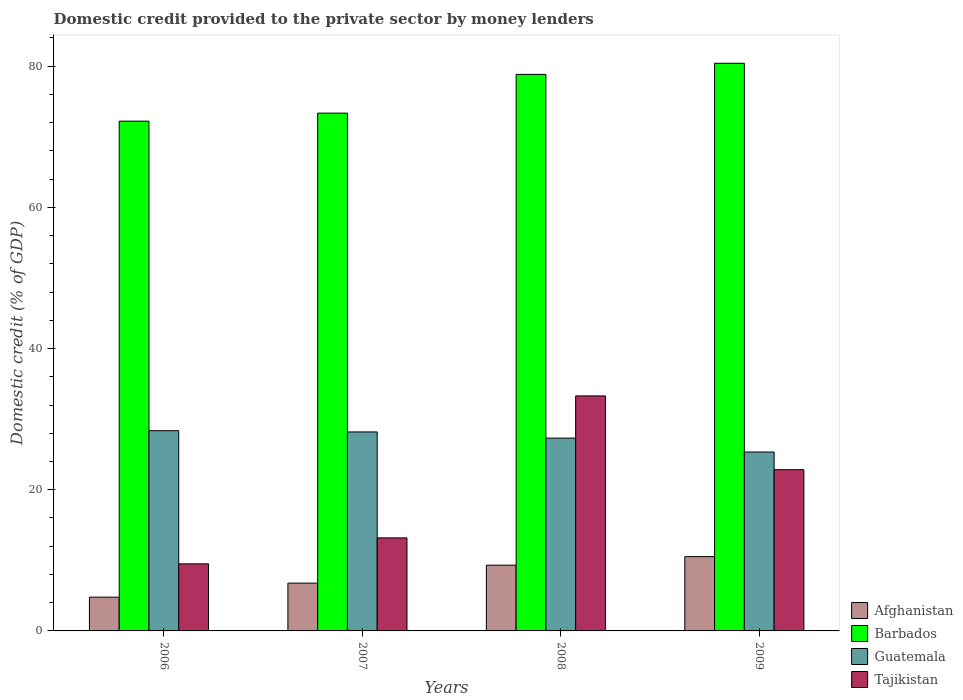How many groups of bars are there?
Your answer should be very brief. 4. Are the number of bars per tick equal to the number of legend labels?
Keep it short and to the point. Yes. Are the number of bars on each tick of the X-axis equal?
Your answer should be very brief. Yes. How many bars are there on the 3rd tick from the right?
Your response must be concise. 4. What is the domestic credit provided to the private sector by money lenders in Tajikistan in 2009?
Your answer should be compact. 22.84. Across all years, what is the maximum domestic credit provided to the private sector by money lenders in Guatemala?
Provide a succinct answer. 28.36. Across all years, what is the minimum domestic credit provided to the private sector by money lenders in Barbados?
Ensure brevity in your answer.  72.21. In which year was the domestic credit provided to the private sector by money lenders in Tajikistan minimum?
Provide a short and direct response. 2006. What is the total domestic credit provided to the private sector by money lenders in Afghanistan in the graph?
Your answer should be very brief. 31.39. What is the difference between the domestic credit provided to the private sector by money lenders in Tajikistan in 2008 and that in 2009?
Provide a short and direct response. 10.45. What is the difference between the domestic credit provided to the private sector by money lenders in Tajikistan in 2009 and the domestic credit provided to the private sector by money lenders in Afghanistan in 2006?
Your answer should be very brief. 18.06. What is the average domestic credit provided to the private sector by money lenders in Guatemala per year?
Your response must be concise. 27.3. In the year 2006, what is the difference between the domestic credit provided to the private sector by money lenders in Afghanistan and domestic credit provided to the private sector by money lenders in Barbados?
Your response must be concise. -67.42. In how many years, is the domestic credit provided to the private sector by money lenders in Guatemala greater than 20 %?
Provide a succinct answer. 4. What is the ratio of the domestic credit provided to the private sector by money lenders in Tajikistan in 2006 to that in 2007?
Provide a short and direct response. 0.72. Is the domestic credit provided to the private sector by money lenders in Barbados in 2006 less than that in 2007?
Your answer should be compact. Yes. Is the difference between the domestic credit provided to the private sector by money lenders in Afghanistan in 2008 and 2009 greater than the difference between the domestic credit provided to the private sector by money lenders in Barbados in 2008 and 2009?
Provide a succinct answer. Yes. What is the difference between the highest and the second highest domestic credit provided to the private sector by money lenders in Barbados?
Offer a terse response. 1.58. What is the difference between the highest and the lowest domestic credit provided to the private sector by money lenders in Guatemala?
Give a very brief answer. 3.02. In how many years, is the domestic credit provided to the private sector by money lenders in Barbados greater than the average domestic credit provided to the private sector by money lenders in Barbados taken over all years?
Ensure brevity in your answer.  2. Is the sum of the domestic credit provided to the private sector by money lenders in Barbados in 2006 and 2008 greater than the maximum domestic credit provided to the private sector by money lenders in Tajikistan across all years?
Provide a short and direct response. Yes. Is it the case that in every year, the sum of the domestic credit provided to the private sector by money lenders in Tajikistan and domestic credit provided to the private sector by money lenders in Guatemala is greater than the sum of domestic credit provided to the private sector by money lenders in Afghanistan and domestic credit provided to the private sector by money lenders in Barbados?
Give a very brief answer. No. What does the 2nd bar from the left in 2008 represents?
Your answer should be very brief. Barbados. What does the 4th bar from the right in 2007 represents?
Provide a short and direct response. Afghanistan. Is it the case that in every year, the sum of the domestic credit provided to the private sector by money lenders in Tajikistan and domestic credit provided to the private sector by money lenders in Barbados is greater than the domestic credit provided to the private sector by money lenders in Afghanistan?
Make the answer very short. Yes. How many bars are there?
Provide a succinct answer. 16. Are all the bars in the graph horizontal?
Your response must be concise. No. How many years are there in the graph?
Give a very brief answer. 4. What is the difference between two consecutive major ticks on the Y-axis?
Ensure brevity in your answer.  20. Does the graph contain any zero values?
Ensure brevity in your answer.  No. Does the graph contain grids?
Make the answer very short. No. How are the legend labels stacked?
Offer a very short reply. Vertical. What is the title of the graph?
Your answer should be very brief. Domestic credit provided to the private sector by money lenders. What is the label or title of the Y-axis?
Your answer should be compact. Domestic credit (% of GDP). What is the Domestic credit (% of GDP) in Afghanistan in 2006?
Provide a short and direct response. 4.78. What is the Domestic credit (% of GDP) of Barbados in 2006?
Provide a succinct answer. 72.21. What is the Domestic credit (% of GDP) in Guatemala in 2006?
Offer a terse response. 28.36. What is the Domestic credit (% of GDP) of Tajikistan in 2006?
Offer a very short reply. 9.5. What is the Domestic credit (% of GDP) of Afghanistan in 2007?
Give a very brief answer. 6.77. What is the Domestic credit (% of GDP) of Barbados in 2007?
Keep it short and to the point. 73.35. What is the Domestic credit (% of GDP) of Guatemala in 2007?
Your answer should be compact. 28.18. What is the Domestic credit (% of GDP) in Tajikistan in 2007?
Your answer should be very brief. 13.18. What is the Domestic credit (% of GDP) in Afghanistan in 2008?
Provide a succinct answer. 9.31. What is the Domestic credit (% of GDP) of Barbados in 2008?
Ensure brevity in your answer.  78.83. What is the Domestic credit (% of GDP) of Guatemala in 2008?
Provide a succinct answer. 27.31. What is the Domestic credit (% of GDP) in Tajikistan in 2008?
Offer a terse response. 33.29. What is the Domestic credit (% of GDP) in Afghanistan in 2009?
Your answer should be very brief. 10.53. What is the Domestic credit (% of GDP) in Barbados in 2009?
Make the answer very short. 80.41. What is the Domestic credit (% of GDP) in Guatemala in 2009?
Give a very brief answer. 25.34. What is the Domestic credit (% of GDP) of Tajikistan in 2009?
Provide a short and direct response. 22.84. Across all years, what is the maximum Domestic credit (% of GDP) of Afghanistan?
Provide a short and direct response. 10.53. Across all years, what is the maximum Domestic credit (% of GDP) of Barbados?
Your response must be concise. 80.41. Across all years, what is the maximum Domestic credit (% of GDP) in Guatemala?
Offer a terse response. 28.36. Across all years, what is the maximum Domestic credit (% of GDP) of Tajikistan?
Offer a terse response. 33.29. Across all years, what is the minimum Domestic credit (% of GDP) in Afghanistan?
Ensure brevity in your answer.  4.78. Across all years, what is the minimum Domestic credit (% of GDP) in Barbados?
Your answer should be very brief. 72.21. Across all years, what is the minimum Domestic credit (% of GDP) in Guatemala?
Offer a terse response. 25.34. Across all years, what is the minimum Domestic credit (% of GDP) of Tajikistan?
Ensure brevity in your answer.  9.5. What is the total Domestic credit (% of GDP) in Afghanistan in the graph?
Your answer should be very brief. 31.39. What is the total Domestic credit (% of GDP) of Barbados in the graph?
Your response must be concise. 304.79. What is the total Domestic credit (% of GDP) of Guatemala in the graph?
Your answer should be compact. 109.2. What is the total Domestic credit (% of GDP) of Tajikistan in the graph?
Your answer should be compact. 78.81. What is the difference between the Domestic credit (% of GDP) in Afghanistan in 2006 and that in 2007?
Ensure brevity in your answer.  -1.99. What is the difference between the Domestic credit (% of GDP) of Barbados in 2006 and that in 2007?
Offer a terse response. -1.14. What is the difference between the Domestic credit (% of GDP) in Guatemala in 2006 and that in 2007?
Make the answer very short. 0.18. What is the difference between the Domestic credit (% of GDP) in Tajikistan in 2006 and that in 2007?
Provide a short and direct response. -3.68. What is the difference between the Domestic credit (% of GDP) of Afghanistan in 2006 and that in 2008?
Your response must be concise. -4.53. What is the difference between the Domestic credit (% of GDP) in Barbados in 2006 and that in 2008?
Give a very brief answer. -6.62. What is the difference between the Domestic credit (% of GDP) of Guatemala in 2006 and that in 2008?
Your answer should be very brief. 1.05. What is the difference between the Domestic credit (% of GDP) in Tajikistan in 2006 and that in 2008?
Your answer should be compact. -23.79. What is the difference between the Domestic credit (% of GDP) in Afghanistan in 2006 and that in 2009?
Keep it short and to the point. -5.74. What is the difference between the Domestic credit (% of GDP) in Barbados in 2006 and that in 2009?
Make the answer very short. -8.2. What is the difference between the Domestic credit (% of GDP) in Guatemala in 2006 and that in 2009?
Provide a succinct answer. 3.02. What is the difference between the Domestic credit (% of GDP) in Tajikistan in 2006 and that in 2009?
Provide a short and direct response. -13.34. What is the difference between the Domestic credit (% of GDP) in Afghanistan in 2007 and that in 2008?
Give a very brief answer. -2.54. What is the difference between the Domestic credit (% of GDP) in Barbados in 2007 and that in 2008?
Ensure brevity in your answer.  -5.48. What is the difference between the Domestic credit (% of GDP) in Guatemala in 2007 and that in 2008?
Your response must be concise. 0.87. What is the difference between the Domestic credit (% of GDP) of Tajikistan in 2007 and that in 2008?
Offer a very short reply. -20.11. What is the difference between the Domestic credit (% of GDP) of Afghanistan in 2007 and that in 2009?
Your answer should be very brief. -3.76. What is the difference between the Domestic credit (% of GDP) in Barbados in 2007 and that in 2009?
Provide a short and direct response. -7.06. What is the difference between the Domestic credit (% of GDP) in Guatemala in 2007 and that in 2009?
Keep it short and to the point. 2.84. What is the difference between the Domestic credit (% of GDP) in Tajikistan in 2007 and that in 2009?
Ensure brevity in your answer.  -9.66. What is the difference between the Domestic credit (% of GDP) in Afghanistan in 2008 and that in 2009?
Give a very brief answer. -1.21. What is the difference between the Domestic credit (% of GDP) in Barbados in 2008 and that in 2009?
Offer a terse response. -1.58. What is the difference between the Domestic credit (% of GDP) of Guatemala in 2008 and that in 2009?
Provide a succinct answer. 1.97. What is the difference between the Domestic credit (% of GDP) in Tajikistan in 2008 and that in 2009?
Your response must be concise. 10.45. What is the difference between the Domestic credit (% of GDP) in Afghanistan in 2006 and the Domestic credit (% of GDP) in Barbados in 2007?
Offer a terse response. -68.56. What is the difference between the Domestic credit (% of GDP) of Afghanistan in 2006 and the Domestic credit (% of GDP) of Guatemala in 2007?
Offer a terse response. -23.4. What is the difference between the Domestic credit (% of GDP) in Afghanistan in 2006 and the Domestic credit (% of GDP) in Tajikistan in 2007?
Your response must be concise. -8.39. What is the difference between the Domestic credit (% of GDP) of Barbados in 2006 and the Domestic credit (% of GDP) of Guatemala in 2007?
Your answer should be very brief. 44.02. What is the difference between the Domestic credit (% of GDP) in Barbados in 2006 and the Domestic credit (% of GDP) in Tajikistan in 2007?
Offer a very short reply. 59.03. What is the difference between the Domestic credit (% of GDP) of Guatemala in 2006 and the Domestic credit (% of GDP) of Tajikistan in 2007?
Give a very brief answer. 15.19. What is the difference between the Domestic credit (% of GDP) in Afghanistan in 2006 and the Domestic credit (% of GDP) in Barbados in 2008?
Give a very brief answer. -74.04. What is the difference between the Domestic credit (% of GDP) of Afghanistan in 2006 and the Domestic credit (% of GDP) of Guatemala in 2008?
Your response must be concise. -22.53. What is the difference between the Domestic credit (% of GDP) of Afghanistan in 2006 and the Domestic credit (% of GDP) of Tajikistan in 2008?
Offer a very short reply. -28.5. What is the difference between the Domestic credit (% of GDP) of Barbados in 2006 and the Domestic credit (% of GDP) of Guatemala in 2008?
Keep it short and to the point. 44.89. What is the difference between the Domestic credit (% of GDP) in Barbados in 2006 and the Domestic credit (% of GDP) in Tajikistan in 2008?
Offer a terse response. 38.92. What is the difference between the Domestic credit (% of GDP) of Guatemala in 2006 and the Domestic credit (% of GDP) of Tajikistan in 2008?
Keep it short and to the point. -4.92. What is the difference between the Domestic credit (% of GDP) of Afghanistan in 2006 and the Domestic credit (% of GDP) of Barbados in 2009?
Keep it short and to the point. -75.62. What is the difference between the Domestic credit (% of GDP) of Afghanistan in 2006 and the Domestic credit (% of GDP) of Guatemala in 2009?
Ensure brevity in your answer.  -20.56. What is the difference between the Domestic credit (% of GDP) of Afghanistan in 2006 and the Domestic credit (% of GDP) of Tajikistan in 2009?
Your answer should be very brief. -18.06. What is the difference between the Domestic credit (% of GDP) in Barbados in 2006 and the Domestic credit (% of GDP) in Guatemala in 2009?
Offer a very short reply. 46.87. What is the difference between the Domestic credit (% of GDP) in Barbados in 2006 and the Domestic credit (% of GDP) in Tajikistan in 2009?
Provide a short and direct response. 49.37. What is the difference between the Domestic credit (% of GDP) in Guatemala in 2006 and the Domestic credit (% of GDP) in Tajikistan in 2009?
Provide a short and direct response. 5.52. What is the difference between the Domestic credit (% of GDP) of Afghanistan in 2007 and the Domestic credit (% of GDP) of Barbados in 2008?
Ensure brevity in your answer.  -72.06. What is the difference between the Domestic credit (% of GDP) of Afghanistan in 2007 and the Domestic credit (% of GDP) of Guatemala in 2008?
Your answer should be very brief. -20.54. What is the difference between the Domestic credit (% of GDP) in Afghanistan in 2007 and the Domestic credit (% of GDP) in Tajikistan in 2008?
Give a very brief answer. -26.52. What is the difference between the Domestic credit (% of GDP) in Barbados in 2007 and the Domestic credit (% of GDP) in Guatemala in 2008?
Offer a terse response. 46.03. What is the difference between the Domestic credit (% of GDP) in Barbados in 2007 and the Domestic credit (% of GDP) in Tajikistan in 2008?
Ensure brevity in your answer.  40.06. What is the difference between the Domestic credit (% of GDP) in Guatemala in 2007 and the Domestic credit (% of GDP) in Tajikistan in 2008?
Your answer should be compact. -5.1. What is the difference between the Domestic credit (% of GDP) in Afghanistan in 2007 and the Domestic credit (% of GDP) in Barbados in 2009?
Give a very brief answer. -73.64. What is the difference between the Domestic credit (% of GDP) in Afghanistan in 2007 and the Domestic credit (% of GDP) in Guatemala in 2009?
Offer a very short reply. -18.57. What is the difference between the Domestic credit (% of GDP) of Afghanistan in 2007 and the Domestic credit (% of GDP) of Tajikistan in 2009?
Provide a short and direct response. -16.07. What is the difference between the Domestic credit (% of GDP) in Barbados in 2007 and the Domestic credit (% of GDP) in Guatemala in 2009?
Keep it short and to the point. 48. What is the difference between the Domestic credit (% of GDP) of Barbados in 2007 and the Domestic credit (% of GDP) of Tajikistan in 2009?
Offer a very short reply. 50.51. What is the difference between the Domestic credit (% of GDP) in Guatemala in 2007 and the Domestic credit (% of GDP) in Tajikistan in 2009?
Offer a very short reply. 5.34. What is the difference between the Domestic credit (% of GDP) of Afghanistan in 2008 and the Domestic credit (% of GDP) of Barbados in 2009?
Provide a short and direct response. -71.09. What is the difference between the Domestic credit (% of GDP) in Afghanistan in 2008 and the Domestic credit (% of GDP) in Guatemala in 2009?
Your answer should be very brief. -16.03. What is the difference between the Domestic credit (% of GDP) of Afghanistan in 2008 and the Domestic credit (% of GDP) of Tajikistan in 2009?
Provide a short and direct response. -13.53. What is the difference between the Domestic credit (% of GDP) in Barbados in 2008 and the Domestic credit (% of GDP) in Guatemala in 2009?
Provide a short and direct response. 53.49. What is the difference between the Domestic credit (% of GDP) of Barbados in 2008 and the Domestic credit (% of GDP) of Tajikistan in 2009?
Your answer should be compact. 55.99. What is the difference between the Domestic credit (% of GDP) of Guatemala in 2008 and the Domestic credit (% of GDP) of Tajikistan in 2009?
Your answer should be compact. 4.47. What is the average Domestic credit (% of GDP) in Afghanistan per year?
Provide a short and direct response. 7.85. What is the average Domestic credit (% of GDP) in Barbados per year?
Provide a succinct answer. 76.2. What is the average Domestic credit (% of GDP) of Guatemala per year?
Keep it short and to the point. 27.3. What is the average Domestic credit (% of GDP) of Tajikistan per year?
Keep it short and to the point. 19.7. In the year 2006, what is the difference between the Domestic credit (% of GDP) of Afghanistan and Domestic credit (% of GDP) of Barbados?
Keep it short and to the point. -67.42. In the year 2006, what is the difference between the Domestic credit (% of GDP) in Afghanistan and Domestic credit (% of GDP) in Guatemala?
Make the answer very short. -23.58. In the year 2006, what is the difference between the Domestic credit (% of GDP) of Afghanistan and Domestic credit (% of GDP) of Tajikistan?
Your response must be concise. -4.72. In the year 2006, what is the difference between the Domestic credit (% of GDP) in Barbados and Domestic credit (% of GDP) in Guatemala?
Make the answer very short. 43.84. In the year 2006, what is the difference between the Domestic credit (% of GDP) of Barbados and Domestic credit (% of GDP) of Tajikistan?
Make the answer very short. 62.71. In the year 2006, what is the difference between the Domestic credit (% of GDP) of Guatemala and Domestic credit (% of GDP) of Tajikistan?
Your response must be concise. 18.86. In the year 2007, what is the difference between the Domestic credit (% of GDP) in Afghanistan and Domestic credit (% of GDP) in Barbados?
Your response must be concise. -66.58. In the year 2007, what is the difference between the Domestic credit (% of GDP) of Afghanistan and Domestic credit (% of GDP) of Guatemala?
Offer a terse response. -21.41. In the year 2007, what is the difference between the Domestic credit (% of GDP) of Afghanistan and Domestic credit (% of GDP) of Tajikistan?
Ensure brevity in your answer.  -6.41. In the year 2007, what is the difference between the Domestic credit (% of GDP) of Barbados and Domestic credit (% of GDP) of Guatemala?
Ensure brevity in your answer.  45.16. In the year 2007, what is the difference between the Domestic credit (% of GDP) in Barbados and Domestic credit (% of GDP) in Tajikistan?
Provide a succinct answer. 60.17. In the year 2007, what is the difference between the Domestic credit (% of GDP) in Guatemala and Domestic credit (% of GDP) in Tajikistan?
Offer a terse response. 15.01. In the year 2008, what is the difference between the Domestic credit (% of GDP) in Afghanistan and Domestic credit (% of GDP) in Barbados?
Offer a very short reply. -69.52. In the year 2008, what is the difference between the Domestic credit (% of GDP) in Afghanistan and Domestic credit (% of GDP) in Guatemala?
Give a very brief answer. -18. In the year 2008, what is the difference between the Domestic credit (% of GDP) in Afghanistan and Domestic credit (% of GDP) in Tajikistan?
Your response must be concise. -23.97. In the year 2008, what is the difference between the Domestic credit (% of GDP) of Barbados and Domestic credit (% of GDP) of Guatemala?
Ensure brevity in your answer.  51.52. In the year 2008, what is the difference between the Domestic credit (% of GDP) of Barbados and Domestic credit (% of GDP) of Tajikistan?
Your answer should be compact. 45.54. In the year 2008, what is the difference between the Domestic credit (% of GDP) of Guatemala and Domestic credit (% of GDP) of Tajikistan?
Keep it short and to the point. -5.98. In the year 2009, what is the difference between the Domestic credit (% of GDP) of Afghanistan and Domestic credit (% of GDP) of Barbados?
Offer a very short reply. -69.88. In the year 2009, what is the difference between the Domestic credit (% of GDP) of Afghanistan and Domestic credit (% of GDP) of Guatemala?
Make the answer very short. -14.82. In the year 2009, what is the difference between the Domestic credit (% of GDP) of Afghanistan and Domestic credit (% of GDP) of Tajikistan?
Offer a very short reply. -12.31. In the year 2009, what is the difference between the Domestic credit (% of GDP) in Barbados and Domestic credit (% of GDP) in Guatemala?
Ensure brevity in your answer.  55.07. In the year 2009, what is the difference between the Domestic credit (% of GDP) of Barbados and Domestic credit (% of GDP) of Tajikistan?
Provide a short and direct response. 57.57. In the year 2009, what is the difference between the Domestic credit (% of GDP) of Guatemala and Domestic credit (% of GDP) of Tajikistan?
Provide a succinct answer. 2.5. What is the ratio of the Domestic credit (% of GDP) in Afghanistan in 2006 to that in 2007?
Provide a short and direct response. 0.71. What is the ratio of the Domestic credit (% of GDP) in Barbados in 2006 to that in 2007?
Offer a very short reply. 0.98. What is the ratio of the Domestic credit (% of GDP) in Guatemala in 2006 to that in 2007?
Your response must be concise. 1.01. What is the ratio of the Domestic credit (% of GDP) in Tajikistan in 2006 to that in 2007?
Make the answer very short. 0.72. What is the ratio of the Domestic credit (% of GDP) of Afghanistan in 2006 to that in 2008?
Keep it short and to the point. 0.51. What is the ratio of the Domestic credit (% of GDP) of Barbados in 2006 to that in 2008?
Provide a short and direct response. 0.92. What is the ratio of the Domestic credit (% of GDP) of Guatemala in 2006 to that in 2008?
Offer a very short reply. 1.04. What is the ratio of the Domestic credit (% of GDP) in Tajikistan in 2006 to that in 2008?
Ensure brevity in your answer.  0.29. What is the ratio of the Domestic credit (% of GDP) of Afghanistan in 2006 to that in 2009?
Provide a succinct answer. 0.45. What is the ratio of the Domestic credit (% of GDP) in Barbados in 2006 to that in 2009?
Give a very brief answer. 0.9. What is the ratio of the Domestic credit (% of GDP) of Guatemala in 2006 to that in 2009?
Provide a short and direct response. 1.12. What is the ratio of the Domestic credit (% of GDP) of Tajikistan in 2006 to that in 2009?
Offer a very short reply. 0.42. What is the ratio of the Domestic credit (% of GDP) in Afghanistan in 2007 to that in 2008?
Ensure brevity in your answer.  0.73. What is the ratio of the Domestic credit (% of GDP) in Barbados in 2007 to that in 2008?
Make the answer very short. 0.93. What is the ratio of the Domestic credit (% of GDP) in Guatemala in 2007 to that in 2008?
Make the answer very short. 1.03. What is the ratio of the Domestic credit (% of GDP) in Tajikistan in 2007 to that in 2008?
Offer a terse response. 0.4. What is the ratio of the Domestic credit (% of GDP) in Afghanistan in 2007 to that in 2009?
Keep it short and to the point. 0.64. What is the ratio of the Domestic credit (% of GDP) of Barbados in 2007 to that in 2009?
Your answer should be very brief. 0.91. What is the ratio of the Domestic credit (% of GDP) in Guatemala in 2007 to that in 2009?
Your response must be concise. 1.11. What is the ratio of the Domestic credit (% of GDP) in Tajikistan in 2007 to that in 2009?
Provide a succinct answer. 0.58. What is the ratio of the Domestic credit (% of GDP) in Afghanistan in 2008 to that in 2009?
Offer a very short reply. 0.88. What is the ratio of the Domestic credit (% of GDP) in Barbados in 2008 to that in 2009?
Ensure brevity in your answer.  0.98. What is the ratio of the Domestic credit (% of GDP) in Guatemala in 2008 to that in 2009?
Keep it short and to the point. 1.08. What is the ratio of the Domestic credit (% of GDP) of Tajikistan in 2008 to that in 2009?
Offer a terse response. 1.46. What is the difference between the highest and the second highest Domestic credit (% of GDP) in Afghanistan?
Offer a terse response. 1.21. What is the difference between the highest and the second highest Domestic credit (% of GDP) of Barbados?
Make the answer very short. 1.58. What is the difference between the highest and the second highest Domestic credit (% of GDP) of Guatemala?
Your response must be concise. 0.18. What is the difference between the highest and the second highest Domestic credit (% of GDP) in Tajikistan?
Provide a succinct answer. 10.45. What is the difference between the highest and the lowest Domestic credit (% of GDP) in Afghanistan?
Your response must be concise. 5.74. What is the difference between the highest and the lowest Domestic credit (% of GDP) in Barbados?
Keep it short and to the point. 8.2. What is the difference between the highest and the lowest Domestic credit (% of GDP) in Guatemala?
Your answer should be very brief. 3.02. What is the difference between the highest and the lowest Domestic credit (% of GDP) in Tajikistan?
Keep it short and to the point. 23.79. 